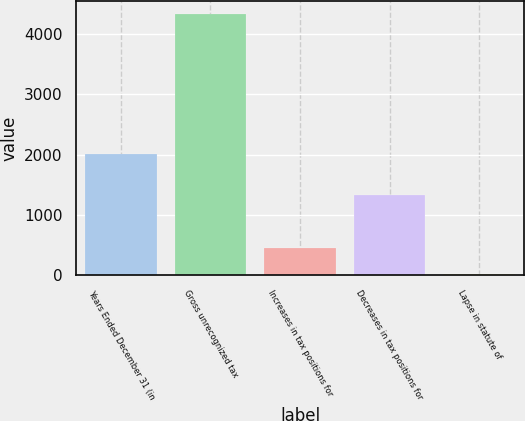Convert chart to OTSL. <chart><loc_0><loc_0><loc_500><loc_500><bar_chart><fcel>Years Ended December 31 (in<fcel>Gross unrecognized tax<fcel>Increases in tax positions for<fcel>Decreases in tax positions for<fcel>Lapse in statute of<nl><fcel>2013<fcel>4340<fcel>456.5<fcel>1329.5<fcel>20<nl></chart> 